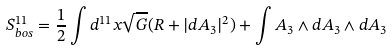Convert formula to latex. <formula><loc_0><loc_0><loc_500><loc_500>S _ { b o s } ^ { 1 1 } = \frac { 1 } { 2 } \int d ^ { 1 1 } x \sqrt { G } ( R + | d A _ { 3 } | ^ { 2 } ) + \int A _ { 3 } \wedge d A _ { 3 } \wedge d A _ { 3 }</formula> 